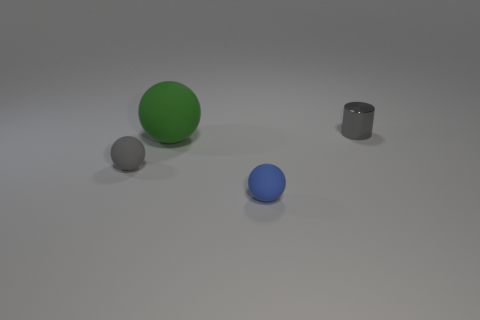Add 3 small rubber objects. How many objects exist? 7 Subtract all balls. How many objects are left? 1 Subtract all large cyan blocks. Subtract all small blue rubber things. How many objects are left? 3 Add 2 blue things. How many blue things are left? 3 Add 3 small green metallic cylinders. How many small green metallic cylinders exist? 3 Subtract 0 yellow balls. How many objects are left? 4 